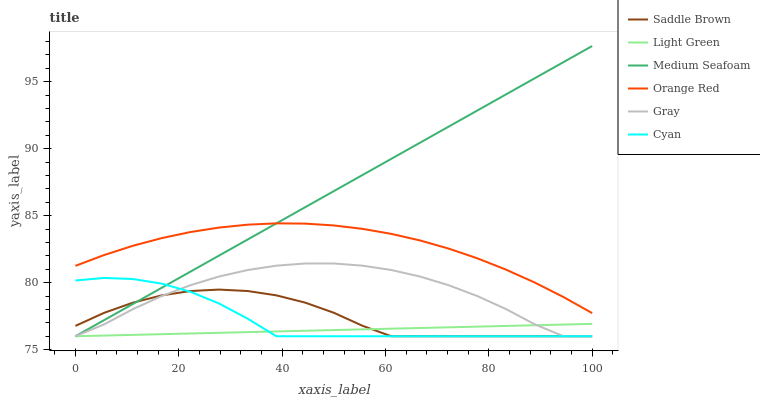Does Light Green have the minimum area under the curve?
Answer yes or no. Yes. Does Medium Seafoam have the maximum area under the curve?
Answer yes or no. Yes. Does Saddle Brown have the minimum area under the curve?
Answer yes or no. No. Does Saddle Brown have the maximum area under the curve?
Answer yes or no. No. Is Medium Seafoam the smoothest?
Answer yes or no. Yes. Is Gray the roughest?
Answer yes or no. Yes. Is Saddle Brown the smoothest?
Answer yes or no. No. Is Saddle Brown the roughest?
Answer yes or no. No. Does Gray have the lowest value?
Answer yes or no. Yes. Does Orange Red have the lowest value?
Answer yes or no. No. Does Medium Seafoam have the highest value?
Answer yes or no. Yes. Does Saddle Brown have the highest value?
Answer yes or no. No. Is Gray less than Orange Red?
Answer yes or no. Yes. Is Orange Red greater than Light Green?
Answer yes or no. Yes. Does Light Green intersect Gray?
Answer yes or no. Yes. Is Light Green less than Gray?
Answer yes or no. No. Is Light Green greater than Gray?
Answer yes or no. No. Does Gray intersect Orange Red?
Answer yes or no. No. 